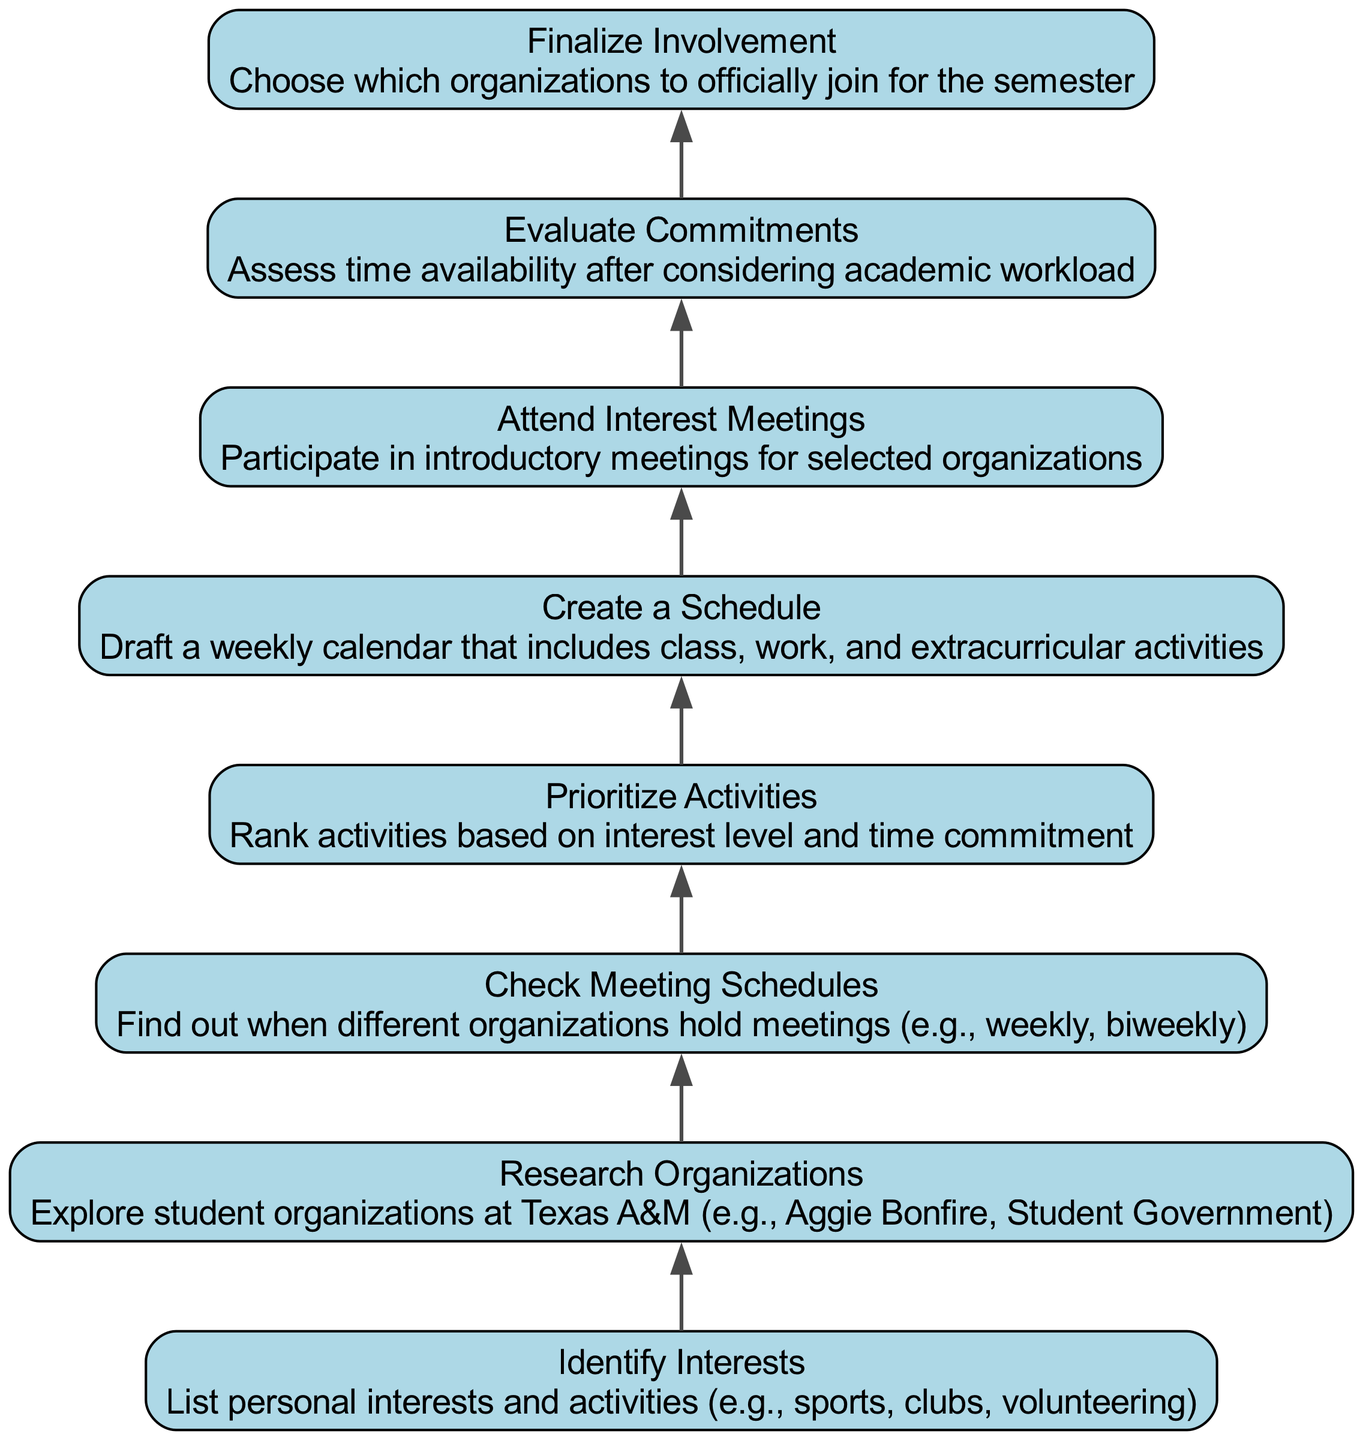What is the first step in the diagram? The first step or node in the diagram is "Identify Interests," which appears at the bottom and serves as the starting point for organizing extracurricular activities.
Answer: Identify Interests How many nodes are present in the diagram? A total of eight nodes are displayed in the diagram, each representing a step in the process of organizing an extracurricular activity schedule.
Answer: 8 Which activity comes immediately after "Research Organizations"? The next step after "Research Organizations" is "Check Meeting Schedules," indicating a sequence in the process of planning extracurricular involvement.
Answer: Check Meeting Schedules What do you do after "Attend Interest Meetings"? The step following "Attend Interest Meetings" is "Evaluate Commitments," showing the flow from attending meetings to considering time availability.
Answer: Evaluate Commitments What is the last step of the process? The last step in the diagram is "Finalize Involvement," which indicates the decision-making stage after evaluating the prior steps of planning and assessment.
Answer: Finalize Involvement Which two activities must be completed before creating a schedule? Before creating a schedule, one must complete "Prioritize Activities" and "Check Meeting Schedules," as these steps inform the overall scheduling process.
Answer: Prioritize Activities, Check Meeting Schedules What is the purpose of the "Evaluate Commitments" step? The purpose of the "Evaluate Commitments" step is to assess time availability after taking into account the academic workload, ensuring a manageable involvement in extracurriculars.
Answer: Assess time availability Which node describes the exploration of student organizations at Texas A&M? The node that describes the exploration is "Research Organizations," as it specifically focuses on looking into the various student groups available at the university.
Answer: Research Organizations 